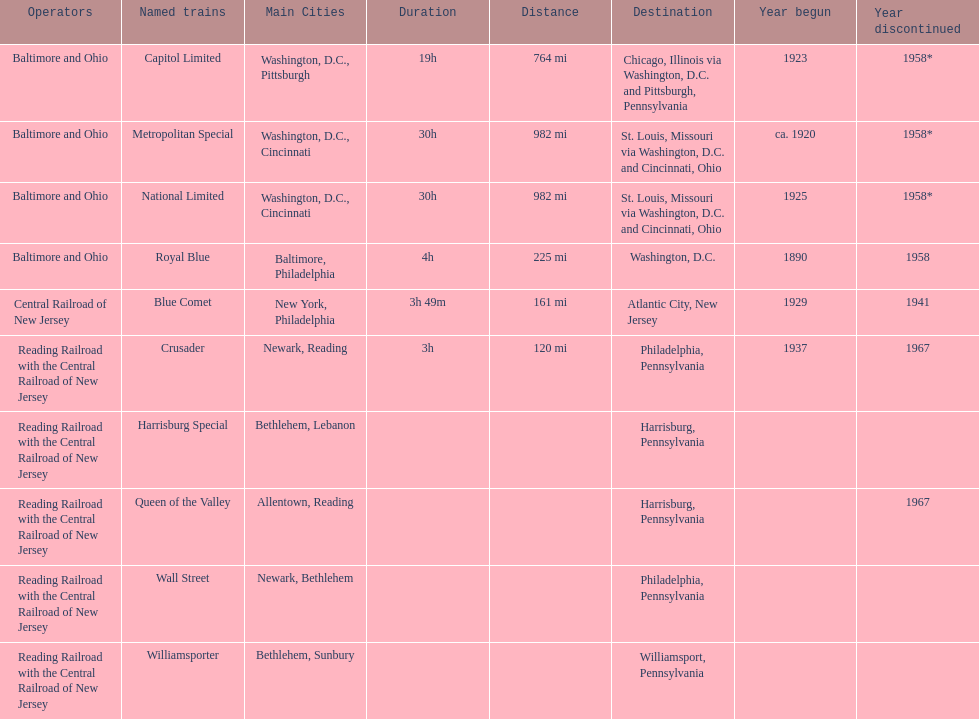Apart from the wall street train, which other train was headed to philadelphia? Crusader. 